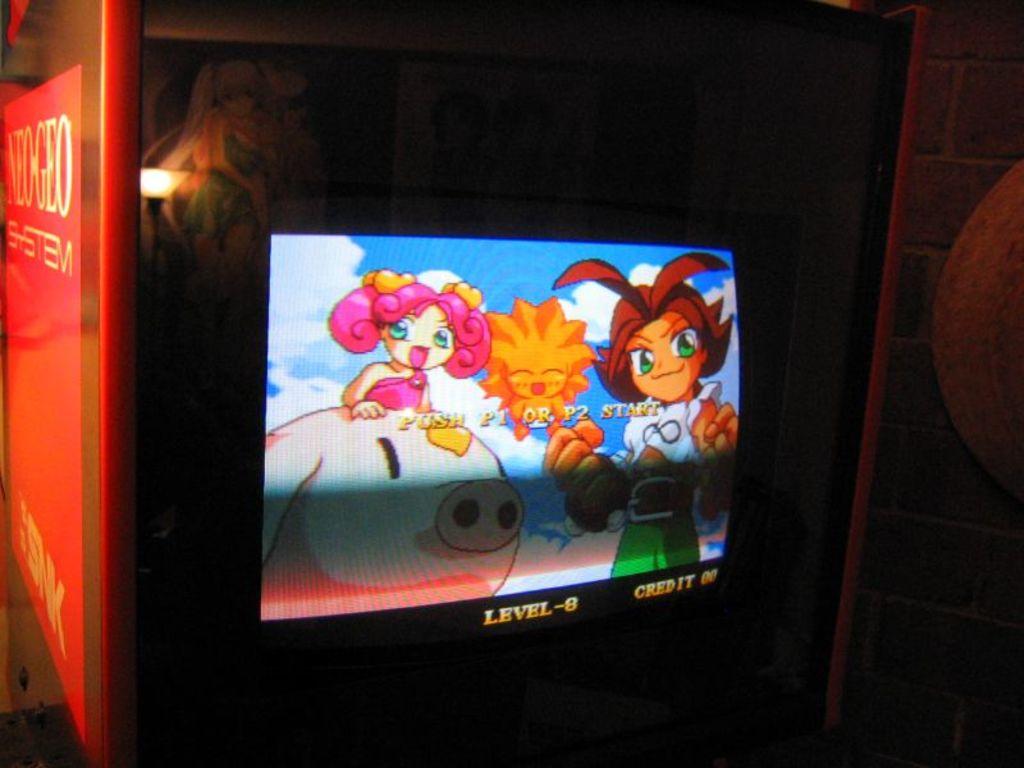What level is the player on?
Your response must be concise. 8. What level is seen here?
Provide a short and direct response. 8. 